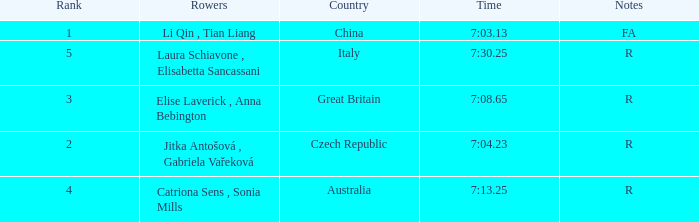What is the Rank of the Rowers with FA as Notes? 1.0. 